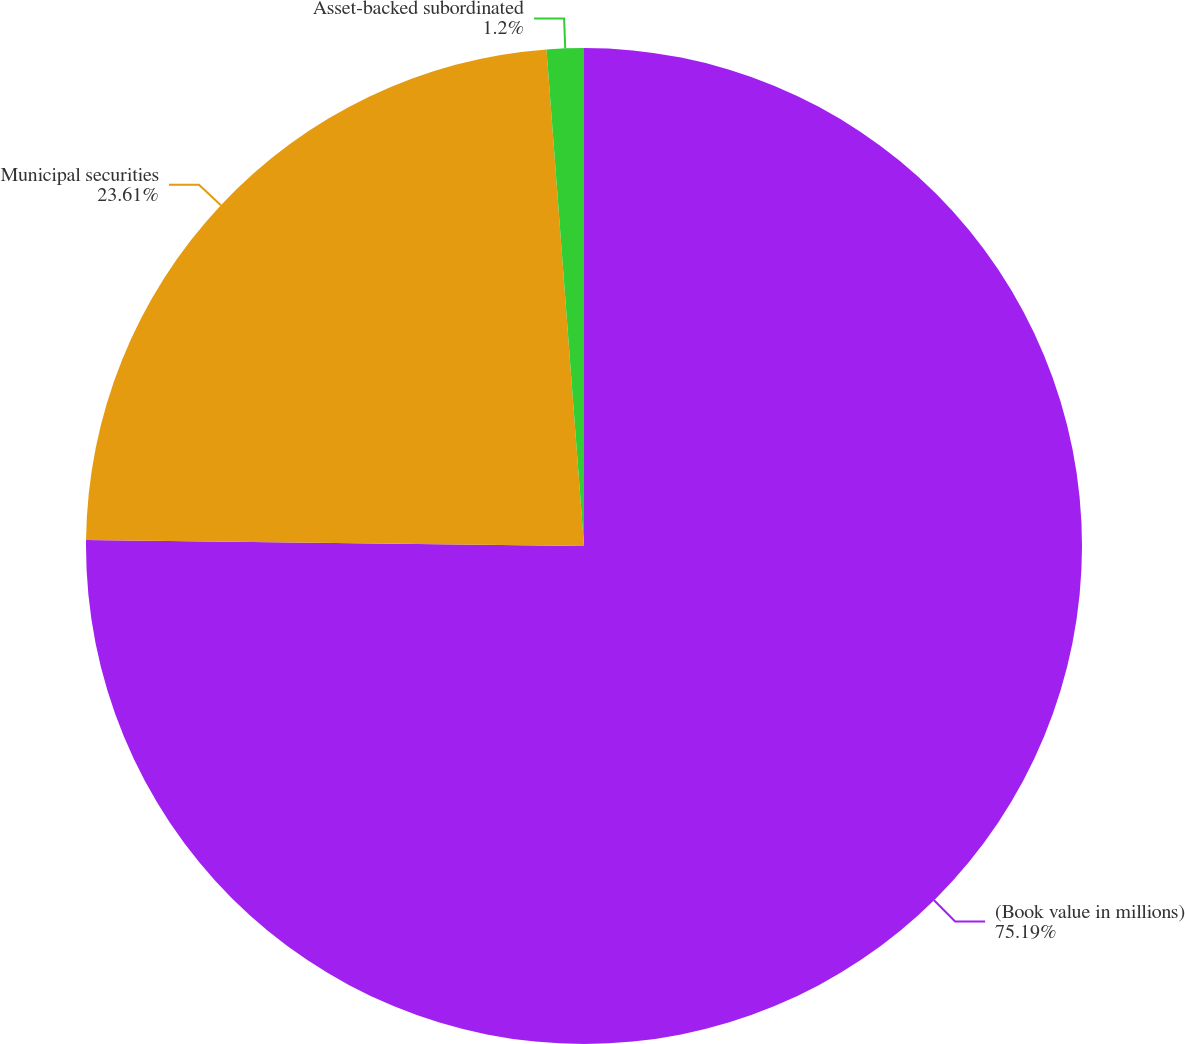Convert chart. <chart><loc_0><loc_0><loc_500><loc_500><pie_chart><fcel>(Book value in millions)<fcel>Municipal securities<fcel>Asset-backed subordinated<nl><fcel>75.19%<fcel>23.61%<fcel>1.2%<nl></chart> 